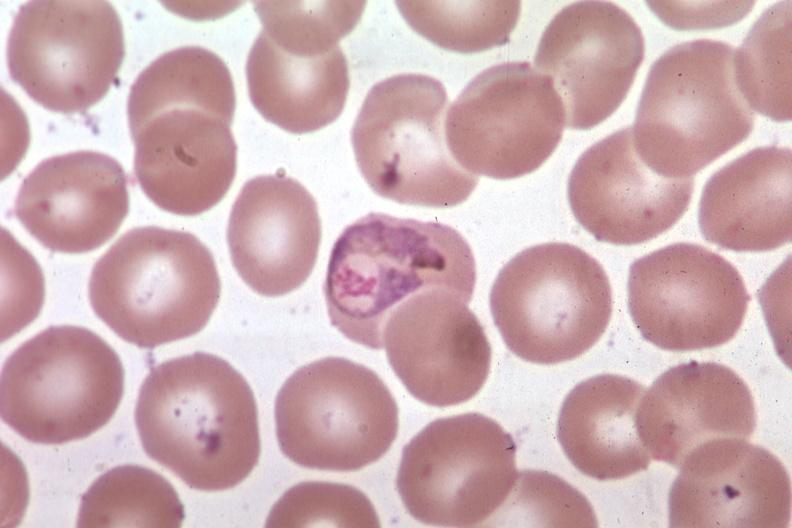what is present?
Answer the question using a single word or phrase. Malaria plasmodium vivax 